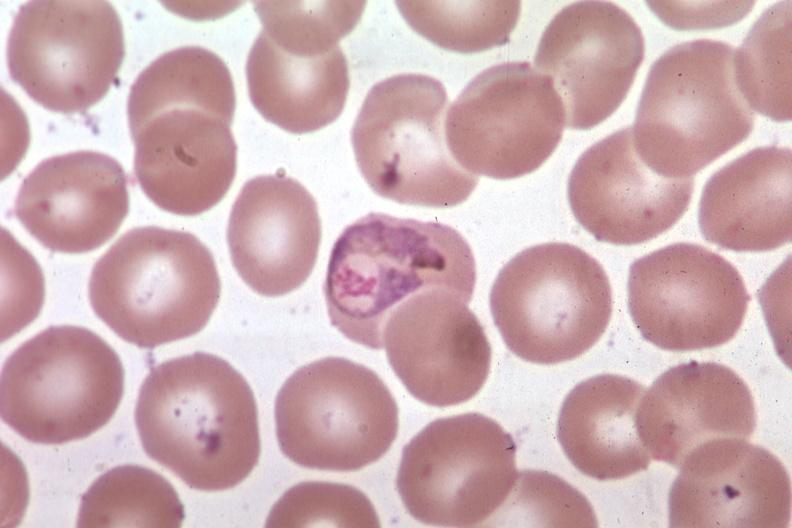what is present?
Answer the question using a single word or phrase. Malaria plasmodium vivax 